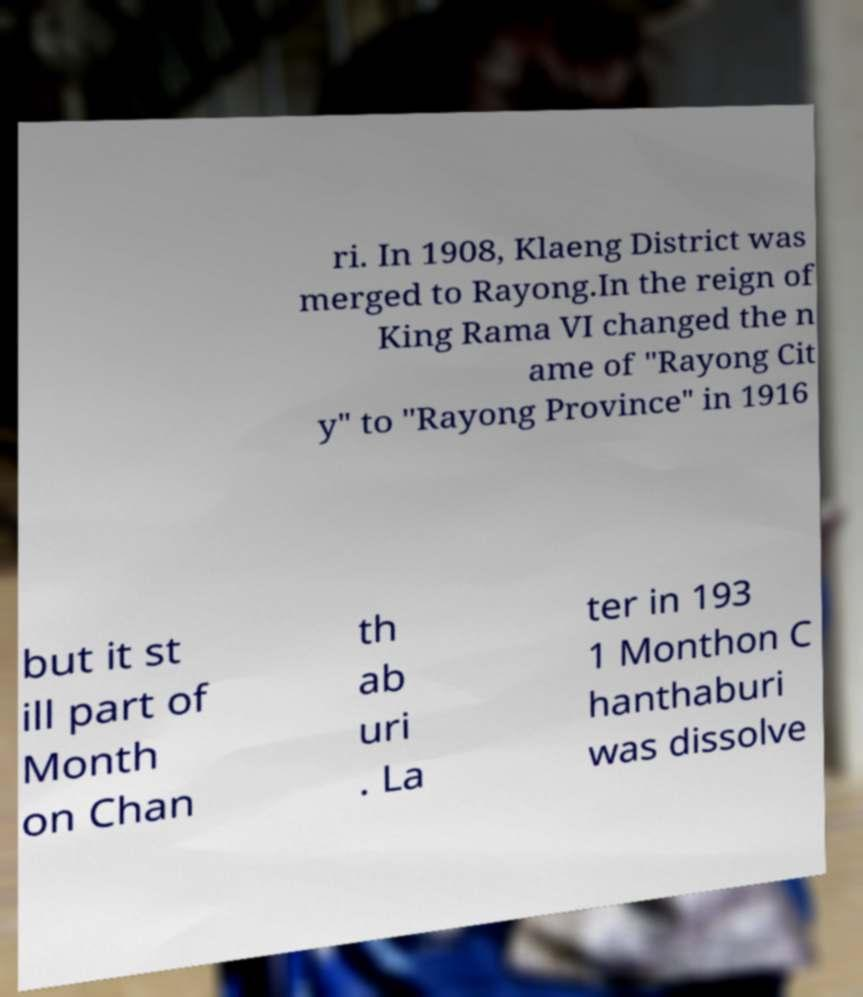Could you assist in decoding the text presented in this image and type it out clearly? ri. In 1908, Klaeng District was merged to Rayong.In the reign of King Rama VI changed the n ame of "Rayong Cit y" to "Rayong Province" in 1916 but it st ill part of Month on Chan th ab uri . La ter in 193 1 Monthon C hanthaburi was dissolve 